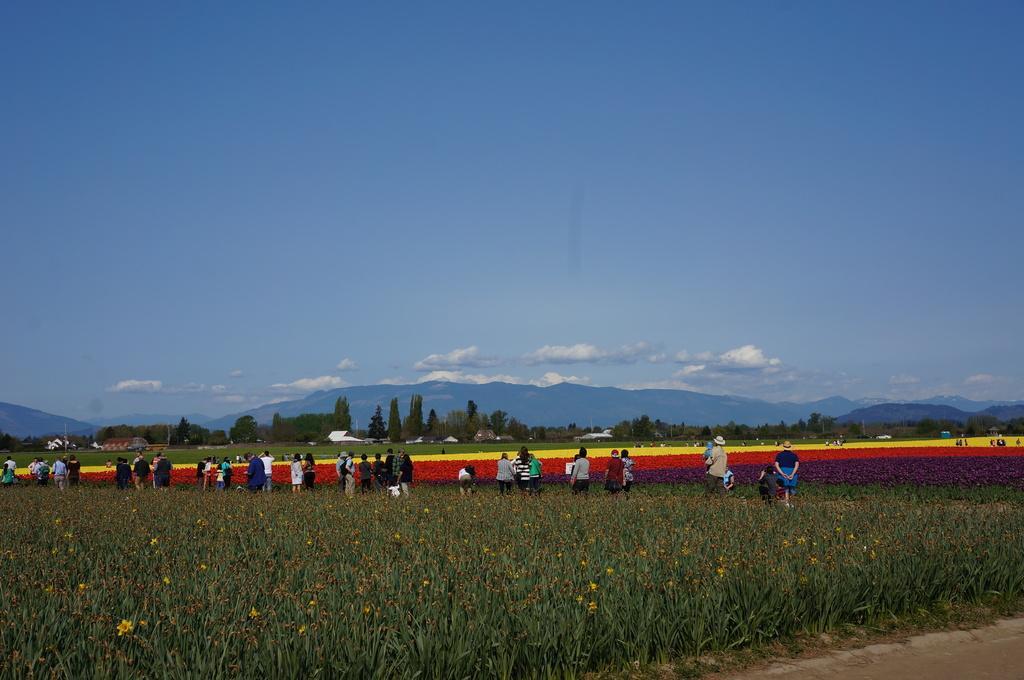Can you describe this image briefly? There are plants. In the back there are many people, flowers, trees, hills and sky with clouds. 